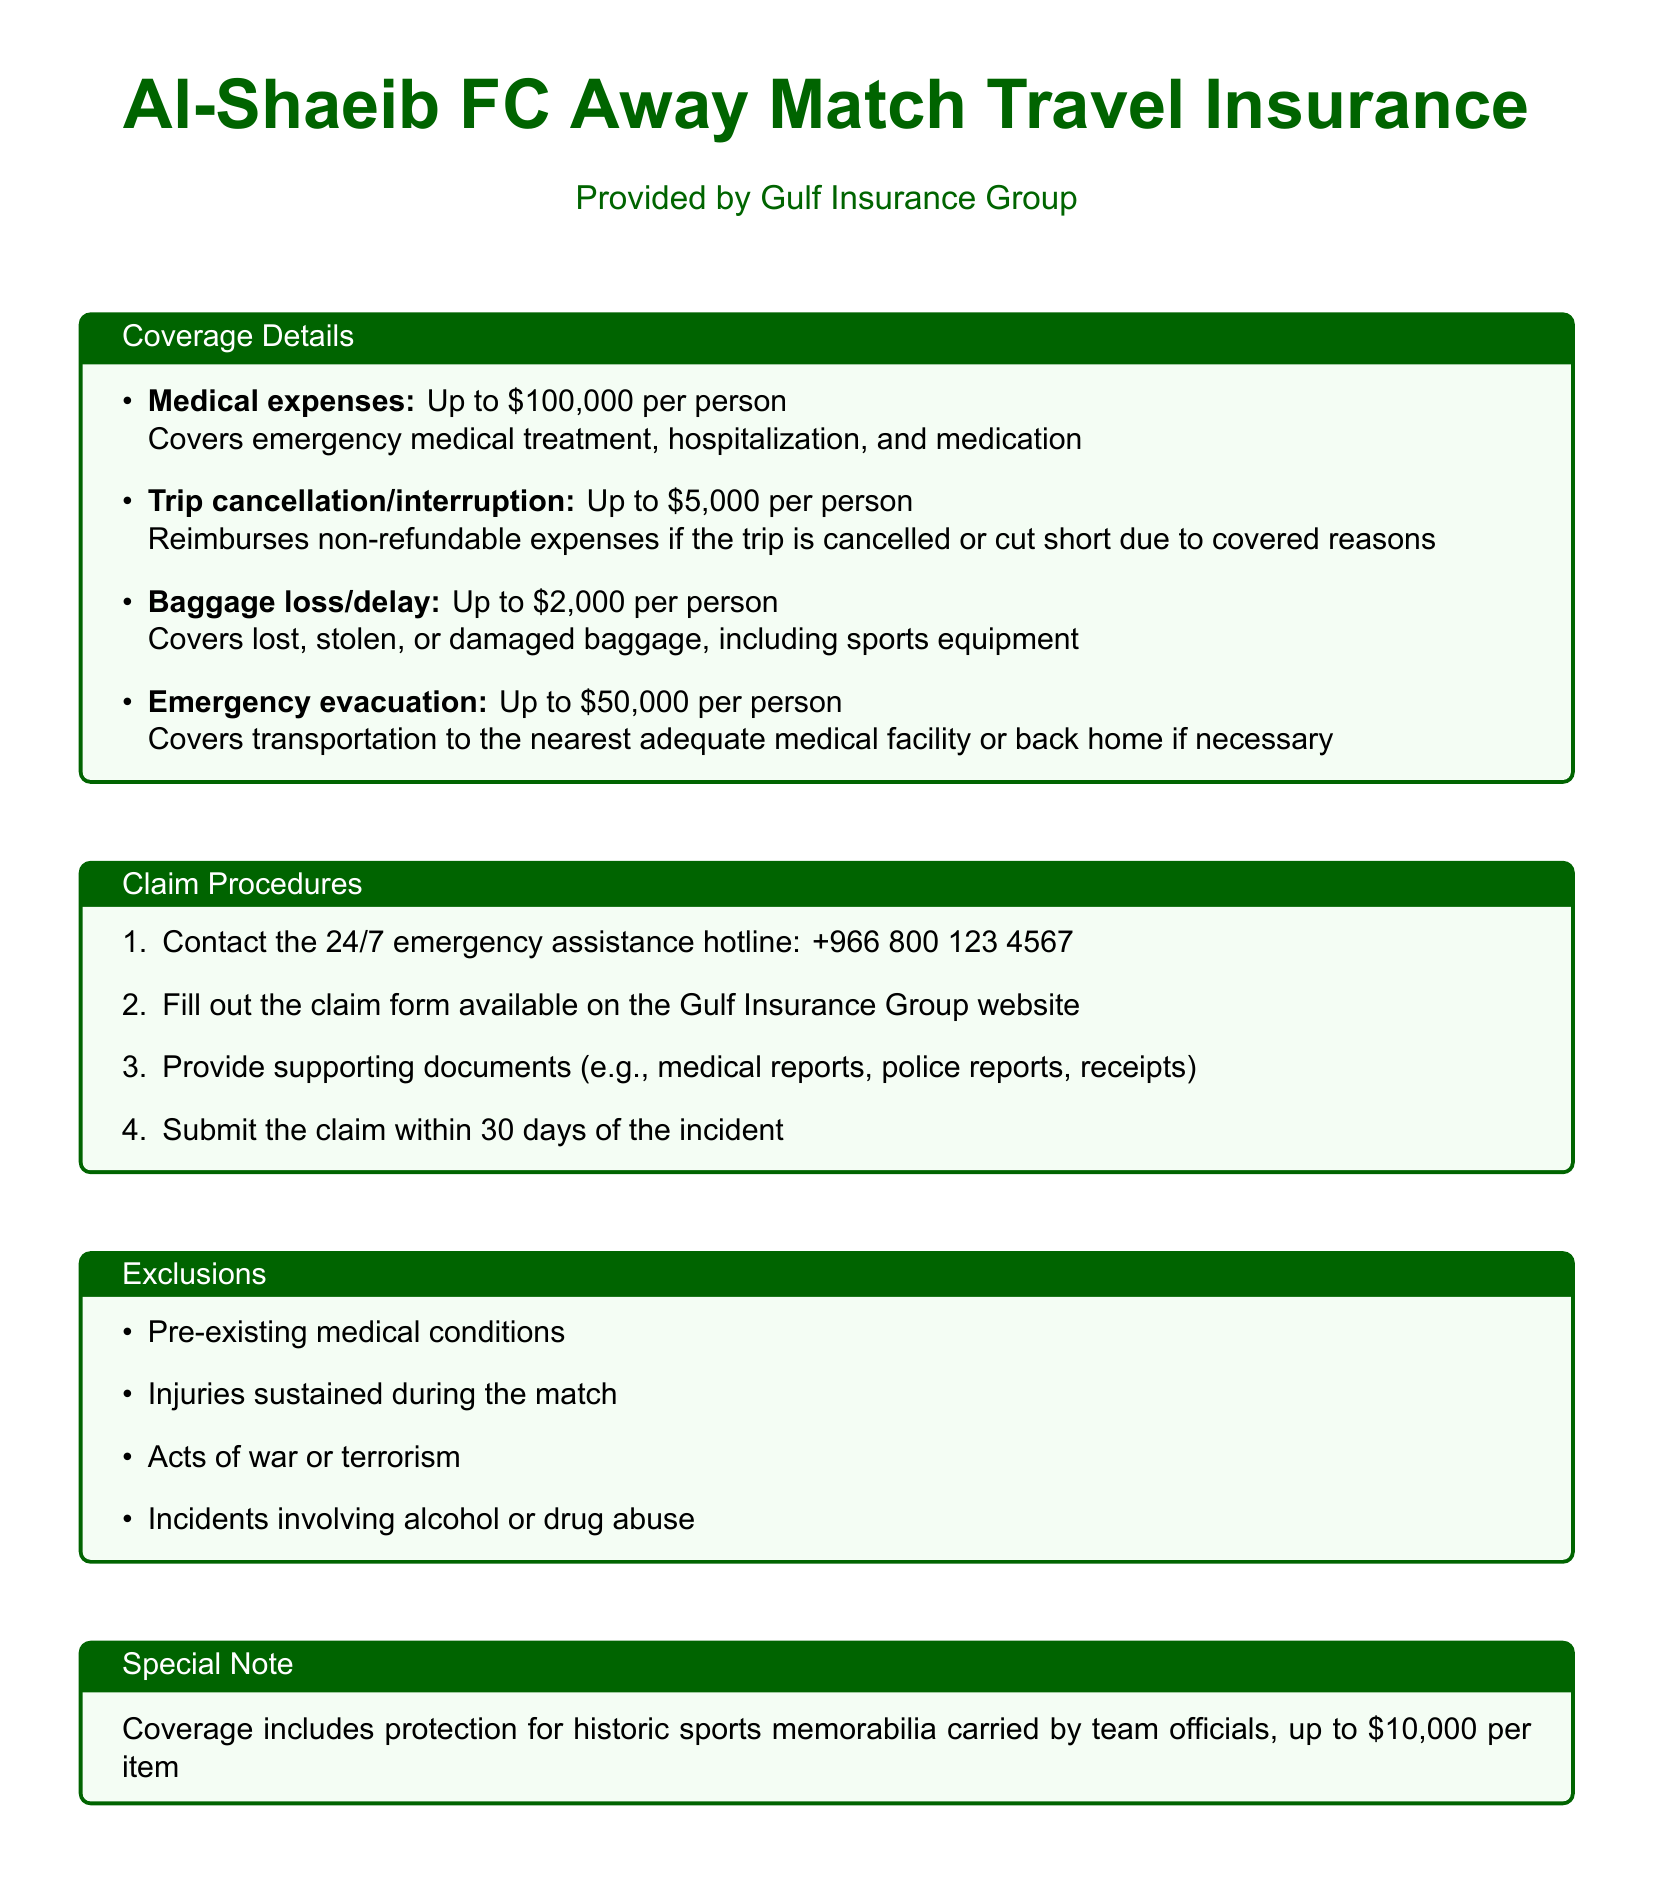what is the maximum coverage for medical expenses? The document states that medical expenses are covered Up to $100,000 per person.
Answer: $100,000 what is the coverage limit for trip cancellation? The document specifies that trip cancellation/interruption is covered Up to $5,000 per person.
Answer: $5,000 which organization provides the travel insurance? The document mentions that the travel insurance is provided by Gulf Insurance Group.
Answer: Gulf Insurance Group how long do you have to submit a claim after the incident? The document states that claims must be submitted within 30 days of the incident.
Answer: 30 days what type of expenses does baggage loss cover? The document indicates that baggage loss/delay covers lost, stolen, or damaged baggage, including sports equipment.
Answer: Lost, stolen, or damaged baggage what is the coverage for historic sports memorabilia? The document notes that historic sports memorabilia carried by team officials is covered up to $10,000 per item.
Answer: $10,000 per item what should you do first in the claim procedures? The document specifies that you should contact the 24/7 emergency assistance hotline as the first step in the claim procedures.
Answer: Contact the emergency assistance hotline what is excluded from the insurance coverage? The document lists pre-existing medical conditions as one of the exclusions from the insurance coverage.
Answer: Pre-existing medical conditions how much coverage is provided for emergency evacuation? The document states that emergency evacuation is covered Up to $50,000 per person.
Answer: $50,000 